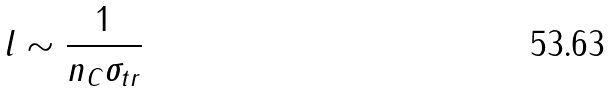<formula> <loc_0><loc_0><loc_500><loc_500>l \sim \frac { 1 } { n _ { C } \sigma _ { t r } }</formula> 